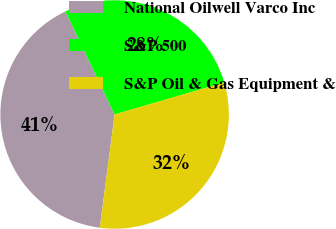<chart> <loc_0><loc_0><loc_500><loc_500><pie_chart><fcel>National Oilwell Varco Inc<fcel>S&P 500<fcel>S&P Oil & Gas Equipment &<nl><fcel>40.85%<fcel>27.57%<fcel>31.58%<nl></chart> 